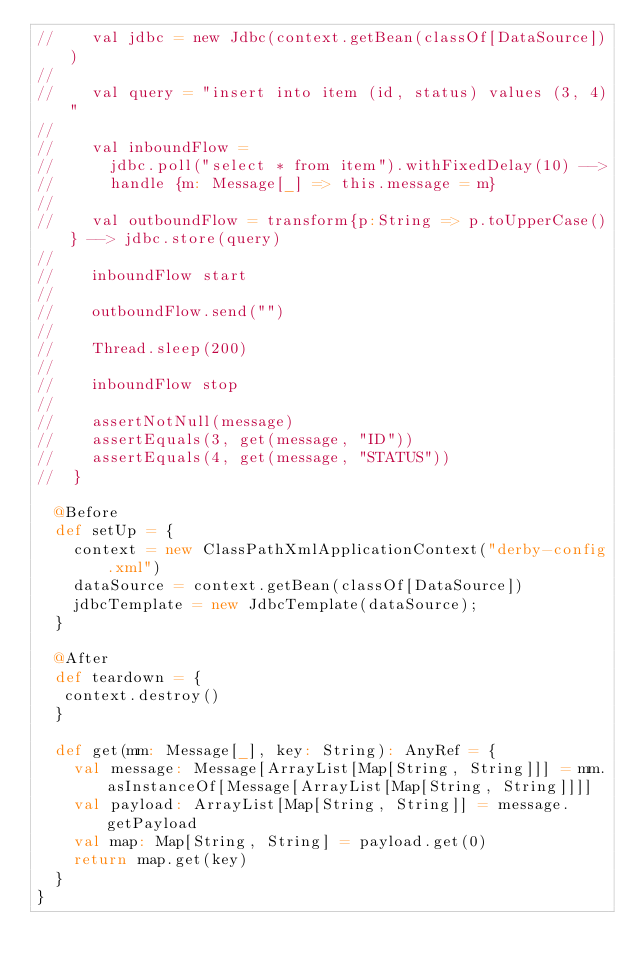Convert code to text. <code><loc_0><loc_0><loc_500><loc_500><_Scala_>//    val jdbc = new Jdbc(context.getBean(classOf[DataSource]))
//    
//    val query = "insert into item (id, status) values (3, 4)"
//
//    val inboundFlow = 
//      jdbc.poll("select * from item").withFixedDelay(10) -->
//      handle {m: Message[_] => this.message = m}
//
//    val outboundFlow = transform{p:String => p.toUpperCase()} --> jdbc.store(query)
//
//    inboundFlow start
//
//    outboundFlow.send("")
//
//    Thread.sleep(200)
//
//    inboundFlow stop
//
//    assertNotNull(message)
//    assertEquals(3, get(message, "ID"))
//    assertEquals(4, get(message, "STATUS"))
//  }
  
  @Before
  def setUp = {
    context = new ClassPathXmlApplicationContext("derby-config.xml")
    dataSource = context.getBean(classOf[DataSource])
    jdbcTemplate = new JdbcTemplate(dataSource);   
  }
  
  @After
  def teardown = {
   context.destroy()
  }

  def get(mm: Message[_], key: String): AnyRef = {
    val message: Message[ArrayList[Map[String, String]]] = mm.asInstanceOf[Message[ArrayList[Map[String, String]]]]
    val payload: ArrayList[Map[String, String]] = message.getPayload
    val map: Map[String, String] = payload.get(0)
    return map.get(key)
  }
}</code> 